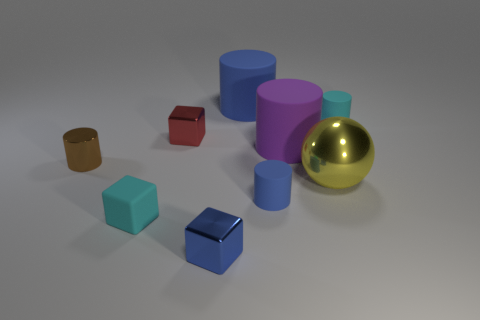What material is the small blue block?
Your answer should be very brief. Metal. How big is the metal thing that is both on the left side of the big blue cylinder and right of the red object?
Your answer should be compact. Small. There is a tiny cylinder that is the same color as the small matte block; what is its material?
Provide a succinct answer. Rubber. What number of rubber cylinders are there?
Offer a terse response. 4. Are there fewer gray rubber cubes than cyan matte cylinders?
Ensure brevity in your answer.  Yes. What material is the cyan block that is the same size as the red block?
Offer a terse response. Rubber. What number of things are small metallic objects or small rubber cylinders?
Keep it short and to the point. 5. What number of matte things are both in front of the shiny cylinder and right of the tiny blue metallic thing?
Your response must be concise. 1. Is the number of tiny blue metal blocks right of the purple rubber thing less than the number of big purple cylinders?
Keep it short and to the point. Yes. There is a red shiny object that is the same size as the brown cylinder; what shape is it?
Provide a succinct answer. Cube. 